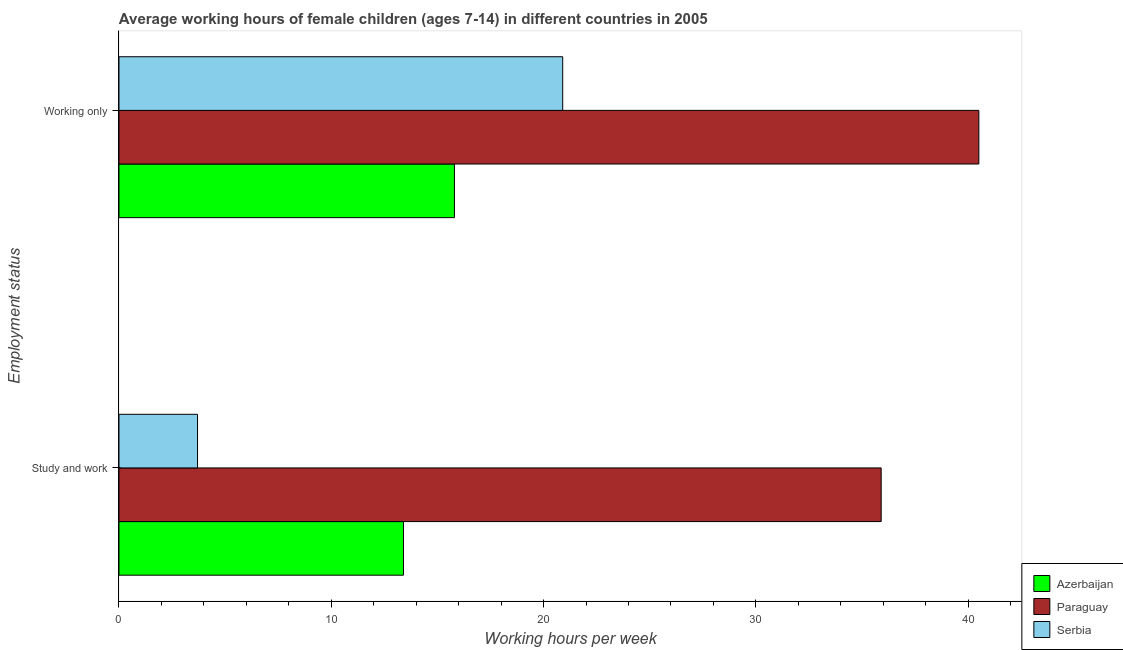How many groups of bars are there?
Your answer should be compact. 2. Are the number of bars on each tick of the Y-axis equal?
Ensure brevity in your answer.  Yes. How many bars are there on the 1st tick from the top?
Make the answer very short. 3. How many bars are there on the 1st tick from the bottom?
Your answer should be compact. 3. What is the label of the 1st group of bars from the top?
Give a very brief answer. Working only. Across all countries, what is the maximum average working hour of children involved in study and work?
Keep it short and to the point. 35.9. In which country was the average working hour of children involved in only work maximum?
Your answer should be compact. Paraguay. In which country was the average working hour of children involved in only work minimum?
Your answer should be compact. Azerbaijan. What is the total average working hour of children involved in only work in the graph?
Provide a succinct answer. 77.2. What is the difference between the average working hour of children involved in study and work in Serbia and that in Azerbaijan?
Give a very brief answer. -9.7. What is the difference between the average working hour of children involved in study and work in Azerbaijan and the average working hour of children involved in only work in Serbia?
Make the answer very short. -7.5. What is the average average working hour of children involved in study and work per country?
Make the answer very short. 17.67. What is the difference between the average working hour of children involved in study and work and average working hour of children involved in only work in Azerbaijan?
Provide a succinct answer. -2.4. What is the ratio of the average working hour of children involved in only work in Paraguay to that in Azerbaijan?
Offer a terse response. 2.56. Is the average working hour of children involved in study and work in Azerbaijan less than that in Paraguay?
Provide a short and direct response. Yes. What does the 1st bar from the top in Study and work represents?
Offer a terse response. Serbia. What does the 2nd bar from the bottom in Working only represents?
Offer a very short reply. Paraguay. How many bars are there?
Offer a very short reply. 6. Are all the bars in the graph horizontal?
Provide a short and direct response. Yes. How many countries are there in the graph?
Your answer should be very brief. 3. What is the difference between two consecutive major ticks on the X-axis?
Make the answer very short. 10. Does the graph contain grids?
Your answer should be very brief. No. Where does the legend appear in the graph?
Offer a terse response. Bottom right. What is the title of the graph?
Ensure brevity in your answer.  Average working hours of female children (ages 7-14) in different countries in 2005. What is the label or title of the X-axis?
Your answer should be compact. Working hours per week. What is the label or title of the Y-axis?
Offer a very short reply. Employment status. What is the Working hours per week of Paraguay in Study and work?
Offer a terse response. 35.9. What is the Working hours per week of Serbia in Study and work?
Ensure brevity in your answer.  3.7. What is the Working hours per week in Paraguay in Working only?
Offer a terse response. 40.5. What is the Working hours per week of Serbia in Working only?
Give a very brief answer. 20.9. Across all Employment status, what is the maximum Working hours per week in Azerbaijan?
Provide a short and direct response. 15.8. Across all Employment status, what is the maximum Working hours per week in Paraguay?
Keep it short and to the point. 40.5. Across all Employment status, what is the maximum Working hours per week of Serbia?
Your response must be concise. 20.9. Across all Employment status, what is the minimum Working hours per week of Paraguay?
Ensure brevity in your answer.  35.9. Across all Employment status, what is the minimum Working hours per week in Serbia?
Your answer should be very brief. 3.7. What is the total Working hours per week in Azerbaijan in the graph?
Offer a very short reply. 29.2. What is the total Working hours per week in Paraguay in the graph?
Provide a succinct answer. 76.4. What is the total Working hours per week of Serbia in the graph?
Offer a terse response. 24.6. What is the difference between the Working hours per week in Serbia in Study and work and that in Working only?
Ensure brevity in your answer.  -17.2. What is the difference between the Working hours per week of Azerbaijan in Study and work and the Working hours per week of Paraguay in Working only?
Provide a short and direct response. -27.1. What is the difference between the Working hours per week in Azerbaijan in Study and work and the Working hours per week in Serbia in Working only?
Provide a succinct answer. -7.5. What is the difference between the Working hours per week of Paraguay in Study and work and the Working hours per week of Serbia in Working only?
Offer a very short reply. 15. What is the average Working hours per week in Azerbaijan per Employment status?
Your answer should be very brief. 14.6. What is the average Working hours per week in Paraguay per Employment status?
Make the answer very short. 38.2. What is the average Working hours per week of Serbia per Employment status?
Your answer should be very brief. 12.3. What is the difference between the Working hours per week in Azerbaijan and Working hours per week in Paraguay in Study and work?
Keep it short and to the point. -22.5. What is the difference between the Working hours per week in Paraguay and Working hours per week in Serbia in Study and work?
Your response must be concise. 32.2. What is the difference between the Working hours per week in Azerbaijan and Working hours per week in Paraguay in Working only?
Your answer should be very brief. -24.7. What is the difference between the Working hours per week of Azerbaijan and Working hours per week of Serbia in Working only?
Keep it short and to the point. -5.1. What is the difference between the Working hours per week of Paraguay and Working hours per week of Serbia in Working only?
Provide a short and direct response. 19.6. What is the ratio of the Working hours per week of Azerbaijan in Study and work to that in Working only?
Your response must be concise. 0.85. What is the ratio of the Working hours per week in Paraguay in Study and work to that in Working only?
Provide a succinct answer. 0.89. What is the ratio of the Working hours per week of Serbia in Study and work to that in Working only?
Your response must be concise. 0.18. What is the difference between the highest and the second highest Working hours per week of Serbia?
Ensure brevity in your answer.  17.2. What is the difference between the highest and the lowest Working hours per week of Serbia?
Make the answer very short. 17.2. 